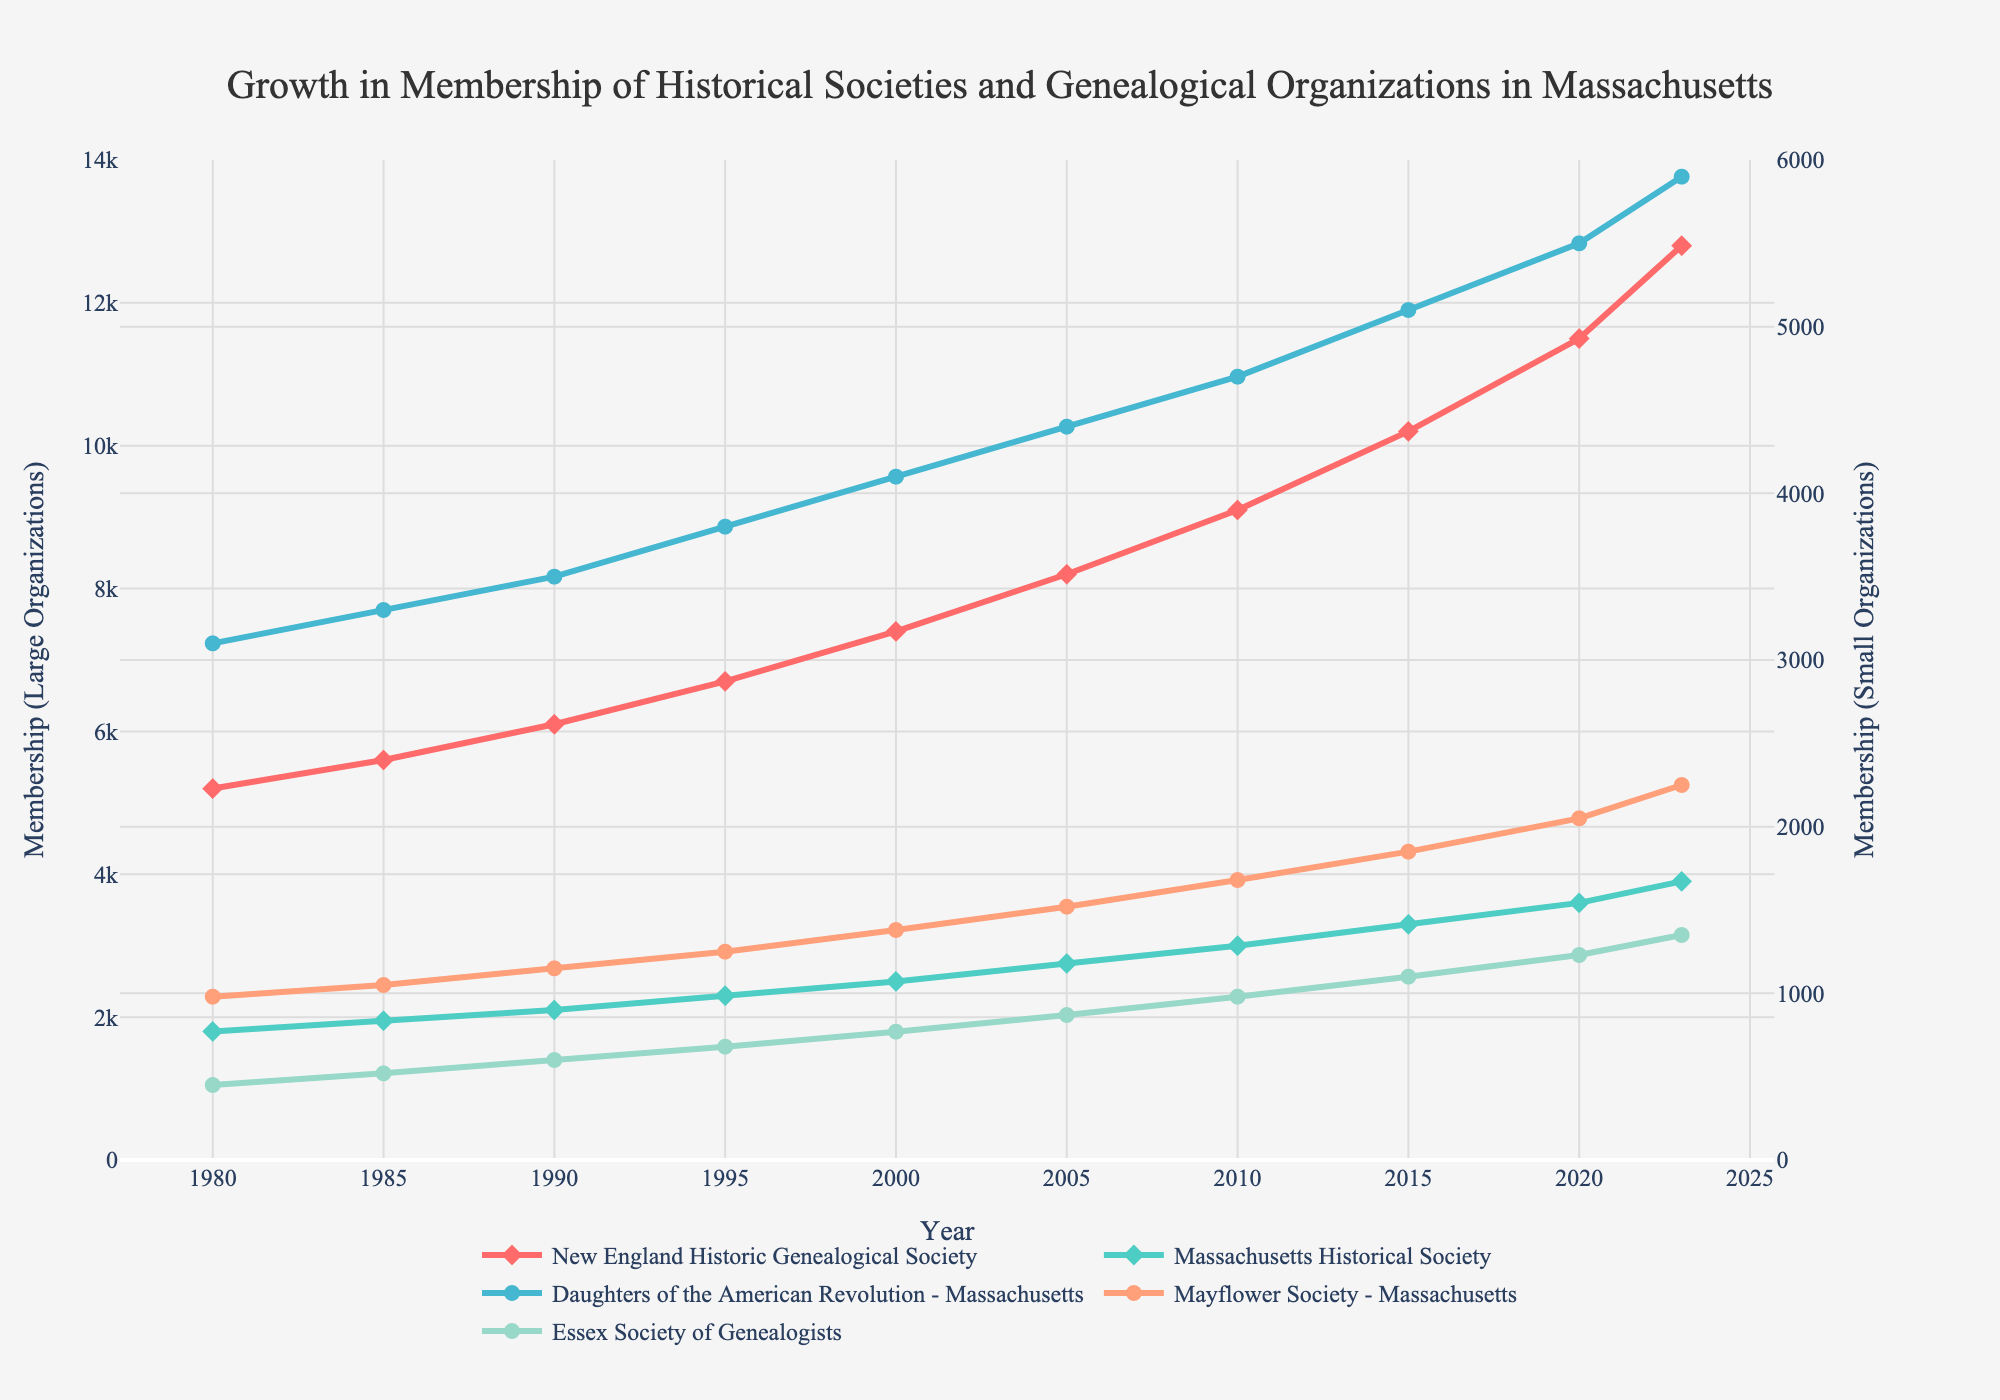which organization had the highest membership in 2023? Look at the data points for 2023 in the figure and identify the organization with the highest value. The New England Historic Genealogical Society is marked clearly above all others.
Answer: New England Historic Genealogical Society what is the difference in membership between the New England Historic Genealogical Society and Massachusetts Historical Society in 2020? Find the data points for both organizations in 2020: New England Historic Genealogical Society (11500) and Massachusetts Historical Society (3600). Subtract the latter from the former: 11500 - 3600.
Answer: 7900 which year saw the highest membership increase for the Mayflower Society - Massachusetts? Examine the increments in membership year-by-year for the Mayflower Society and identify the year with the largest change in membership. The largest increase occurs between 2015 (1850) and 2020 (2050).
Answer: 2015-2020 how does the membership trend of Essex Society of Genealogists compare to the New England Historic Genealogical Society? The New England Historic Genealogical Society shows a steep and steady increase in membership over the years while the Essex Society of Genealogists shows a slower increase with consistently smaller numbers.
Answer: New England Historic Genealogical Society grows faster in how many years did the Massachusetts Historical Society have membership values above 2500? Check the graph to count the number of years Massachusetts Historical Society's membership was above 2500: it was above 2500 during 2005 (2750), 2010 (3000), 2015 (3300), 2020 (3600), and 2023 (3900).
Answer: 5 years what is the average membership of the Daughters of the American Revolution - Massachusetts from 1980 to 2023? Sum the membership values of the Daughters of the American Revolution - Massachusetts from the data points 1980 (3100), 1985 (3300), 1990 (3500), 1995 (3800), 2000 (4100), 2005 (4400), 2010 (4700), 2015 (5100), 2020 (5500), 2023 (5900). The sum is 42400. Divide this by the number of data points (10) to get the average: 42400 / 10.
Answer: 4240 which two organizations have similar trends and what year do they intersect? Look at the trends in the figure. The Daughters of the American Revolution - Massachusetts and Mayflower Society - Massachusetts have nearly parallel growth rates and intersect around the year 2010.
Answer: Daughters of the American Revolution - Massachusetts and Mayflower Society - Massachusetts; 2010 which organization had the smallest membership in 1990? Check the data points for 1990 and identify the smallest value. The Essex Society of Genealogists had the smallest membership at 600.
Answer: Essex Society of Genealogists 